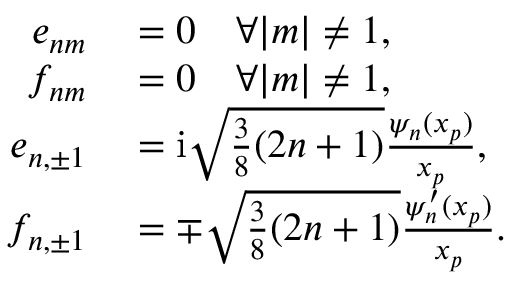<formula> <loc_0><loc_0><loc_500><loc_500>\begin{array} { r l } { e _ { n m } } & = 0 \quad \forall | m | \neq 1 , } \\ { f _ { n m } } & = 0 \quad \forall | m | \neq 1 , } \\ { e _ { n , \pm 1 } } & = i \sqrt { \frac { 3 } { 8 } ( 2 n + 1 ) } \frac { \psi _ { n } ( x _ { p } ) } { x _ { p } } , } \\ { f _ { n , \pm 1 } } & = \mp \sqrt { \frac { 3 } { 8 } ( 2 n + 1 ) } \frac { \psi _ { n } ^ { \prime } ( x _ { p } ) } { x _ { p } } . } \end{array}</formula> 